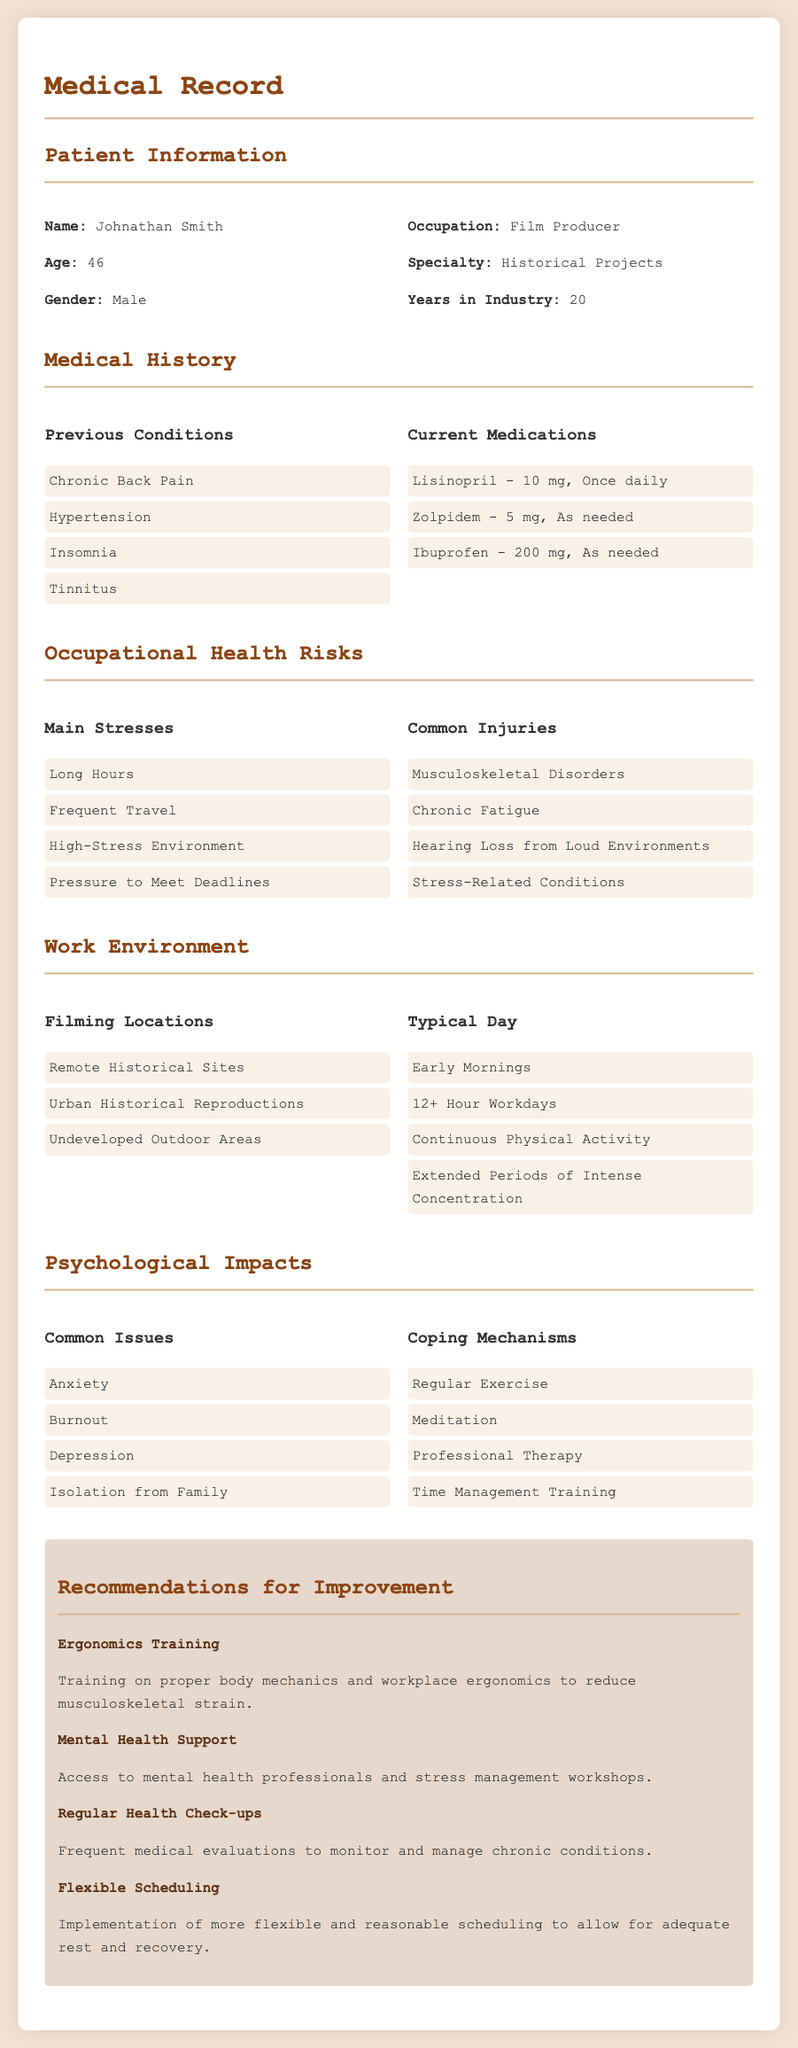What is the name of the patient? The document explicitly states the patient's name in the patient information section.
Answer: Johnathan Smith How many years has the patient been in the industry? The document provides the total years of experience for the patient in the respective section.
Answer: 20 What is the patient's current medication for hypertension? The document lists the specific medication prescribed for the patient's hypertension condition.
Answer: Lisinopril - 10 mg, Once daily What are the main stresses identified for the patient? The document includes a bullet list of main stresses related to the patient's occupation.
Answer: Long Hours What common issue is associated with the psychological impacts for the patient? The document lists common psychological issues experienced by the patient in a specific section.
Answer: Anxiety What ergonomic recommendation is provided in the document? The recommendations section suggests specific measures to improve the patient's work environment.
Answer: Ergonomics Training What type of work does the patient specialize in? The information regarding the patient's specialty is clearly stated in the document.
Answer: Historical Projects Which coping mechanism is suggested in the document? The document specifies coping mechanisms that may help the patient deal with psychological impacts.
Answer: Regular Exercise 